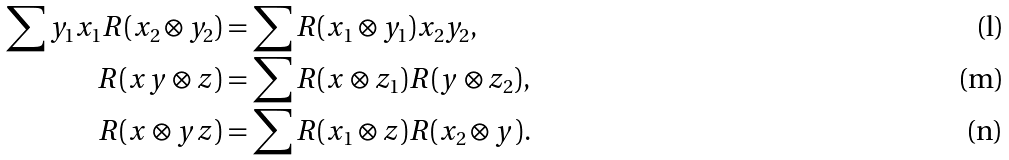Convert formula to latex. <formula><loc_0><loc_0><loc_500><loc_500>\sum y _ { 1 } x _ { 1 } R ( x _ { 2 } \otimes y _ { 2 } ) & = \sum R ( x _ { 1 } \otimes y _ { 1 } ) x _ { 2 } y _ { 2 } , \\ R ( x y \otimes z ) & = \sum R ( x \otimes z _ { 1 } ) R ( y \otimes z _ { 2 } ) , \\ R ( x \otimes y z ) & = \sum R ( x _ { 1 } \otimes z ) R ( x _ { 2 } \otimes y ) .</formula> 